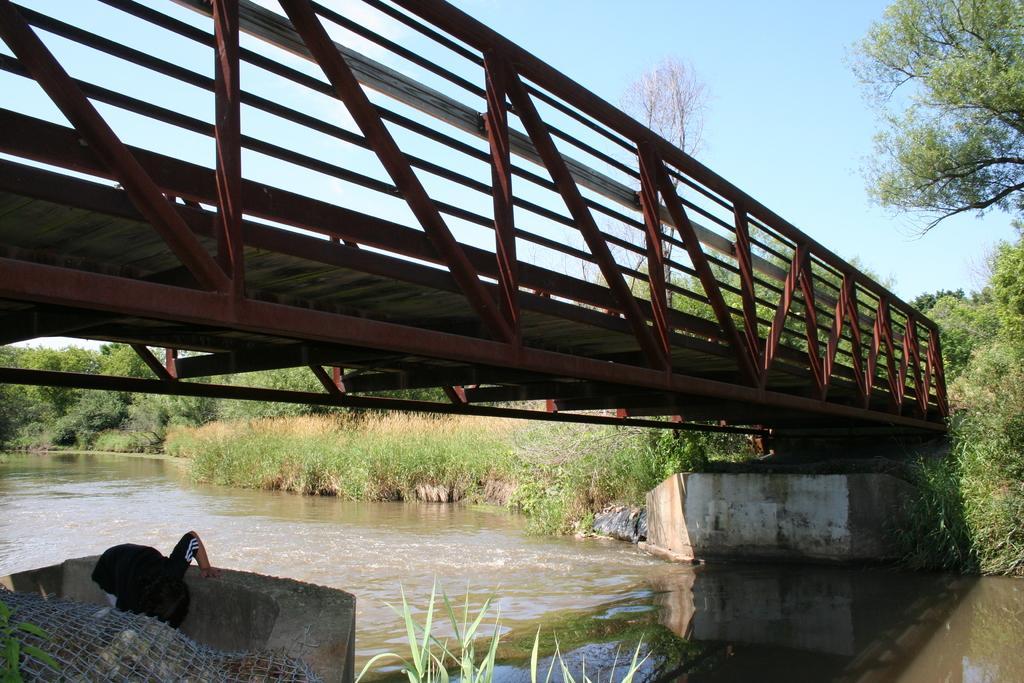Please provide a concise description of this image. It is an iron bridge, at the down side there is water. At the top it is the sky. 